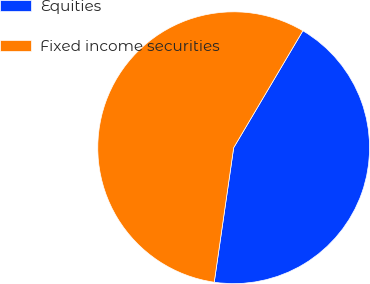<chart> <loc_0><loc_0><loc_500><loc_500><pie_chart><fcel>Equities<fcel>Fixed income securities<nl><fcel>43.78%<fcel>56.22%<nl></chart> 